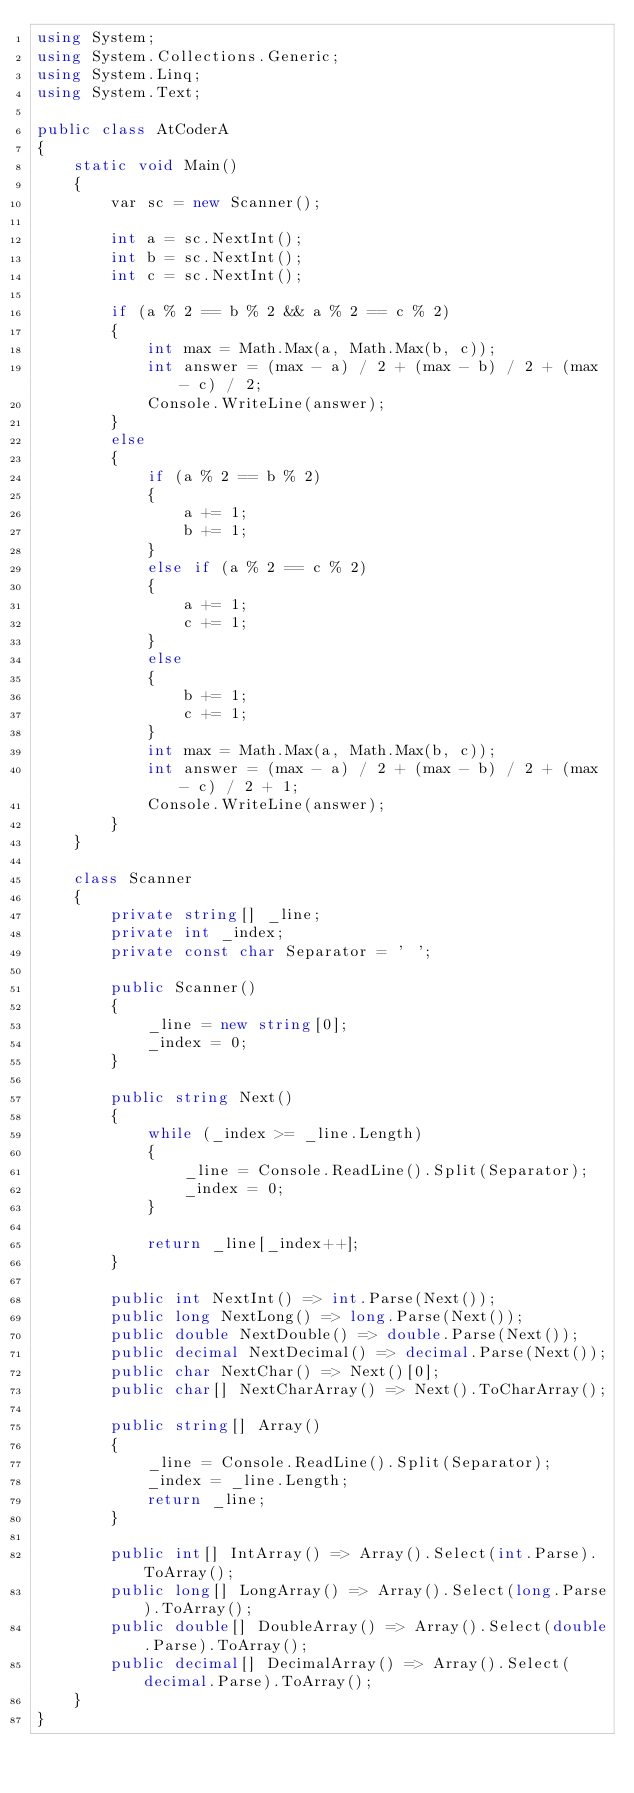<code> <loc_0><loc_0><loc_500><loc_500><_C#_>using System;
using System.Collections.Generic;
using System.Linq;
using System.Text;

public class AtCoderA
{
    static void Main()
    {
        var sc = new Scanner();

        int a = sc.NextInt();
        int b = sc.NextInt();
        int c = sc.NextInt();

        if (a % 2 == b % 2 && a % 2 == c % 2)
        {
            int max = Math.Max(a, Math.Max(b, c));
            int answer = (max - a) / 2 + (max - b) / 2 + (max - c) / 2;
            Console.WriteLine(answer);
        }
        else
        {
            if (a % 2 == b % 2)
            {
                a += 1;
                b += 1;
            }
            else if (a % 2 == c % 2)
            {
                a += 1;
                c += 1;
            }
            else
            {
                b += 1;
                c += 1;
            }
            int max = Math.Max(a, Math.Max(b, c));
            int answer = (max - a) / 2 + (max - b) / 2 + (max - c) / 2 + 1;
            Console.WriteLine(answer);
        }
    }

    class Scanner
    {
        private string[] _line;
        private int _index;
        private const char Separator = ' ';

        public Scanner()
        {
            _line = new string[0];
            _index = 0;
        }

        public string Next()
        {
            while (_index >= _line.Length)
            {
                _line = Console.ReadLine().Split(Separator);
                _index = 0;
            }

            return _line[_index++];
        }

        public int NextInt() => int.Parse(Next());
        public long NextLong() => long.Parse(Next());
        public double NextDouble() => double.Parse(Next());
        public decimal NextDecimal() => decimal.Parse(Next());
        public char NextChar() => Next()[0];
        public char[] NextCharArray() => Next().ToCharArray();

        public string[] Array()
        {
            _line = Console.ReadLine().Split(Separator);
            _index = _line.Length;
            return _line;
        }

        public int[] IntArray() => Array().Select(int.Parse).ToArray();
        public long[] LongArray() => Array().Select(long.Parse).ToArray();
        public double[] DoubleArray() => Array().Select(double.Parse).ToArray();
        public decimal[] DecimalArray() => Array().Select(decimal.Parse).ToArray();
    }
}</code> 